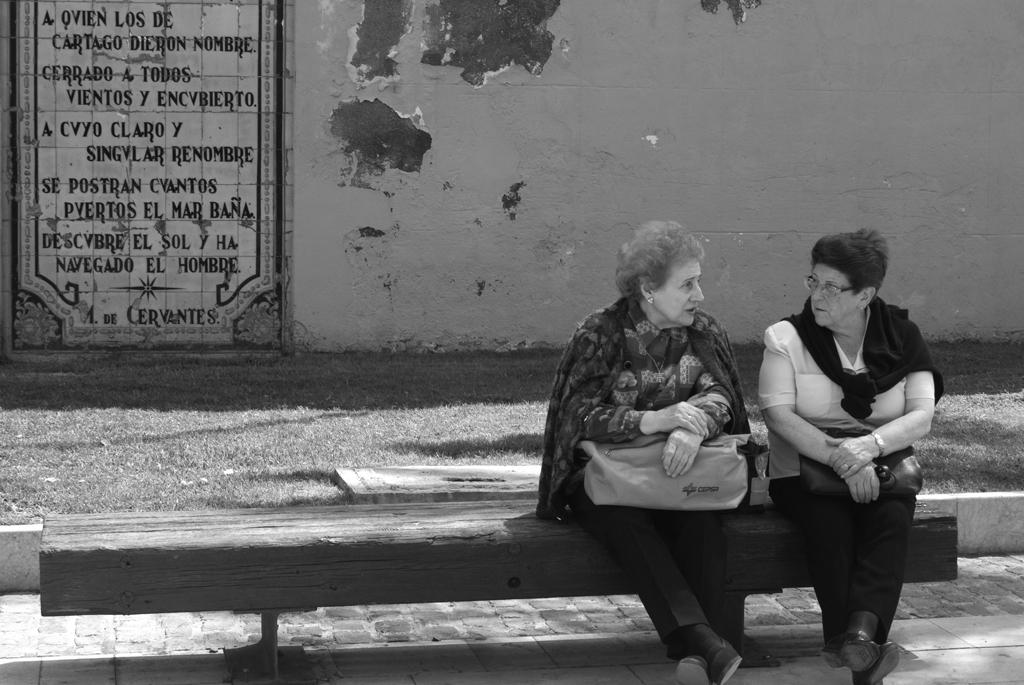How many women are in the image? There are two women in the foreground of the image. What are the women doing in the image? The women are sitting on a bench. What are the women holding in the image? The women are holding bags. What can be seen in the background of the image? There is a wall and a board in the background of the image. What time of day was the image likely taken? The image was likely taken during the day, as there is no indication of darkness or artificial lighting. How many planes can be seen flying over the women in the image? There are no planes visible in the image. What type of tomatoes are being grown on the board in the background? There are no tomatoes present in the image, and the board does not appear to be a garden or planting area. 